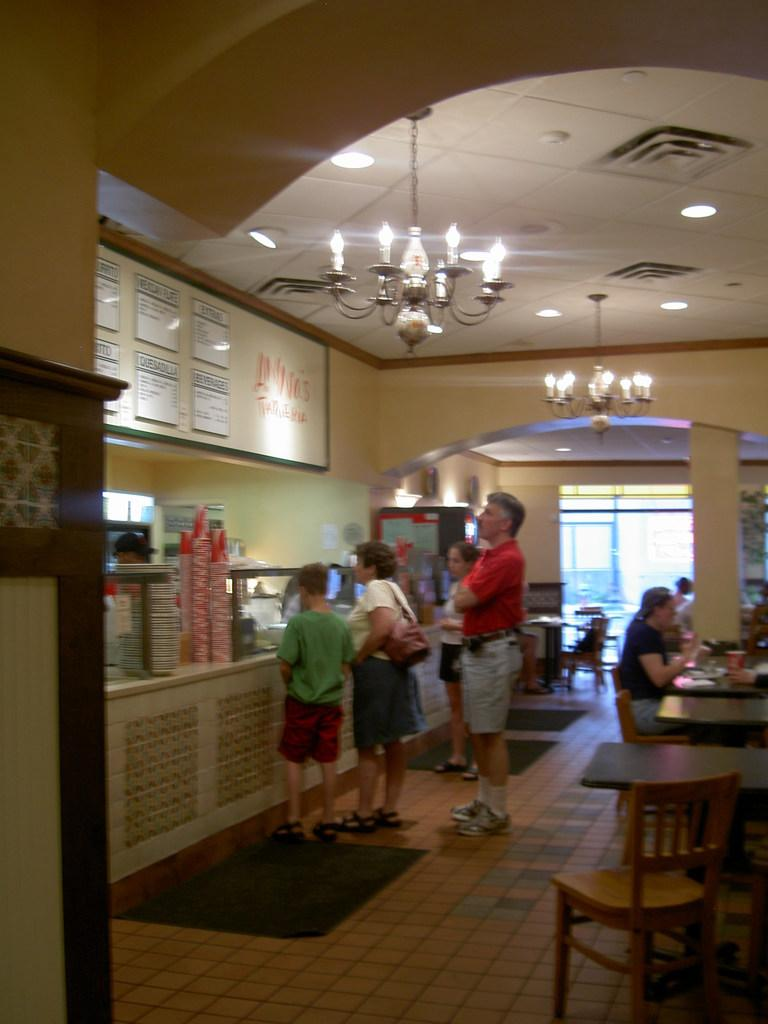How many people are the people are in the image? There are people in the image, but the exact number is not specified. What are the people doing in the image? Some people are sitting, while others are standing. What type of furniture is present in the image? There are chairs and tables in the image. What objects can be seen on the tables? There are glasses in the image. What type of sock is being used as a pancake topping in the image? There is no sock or pancake present in the image. 